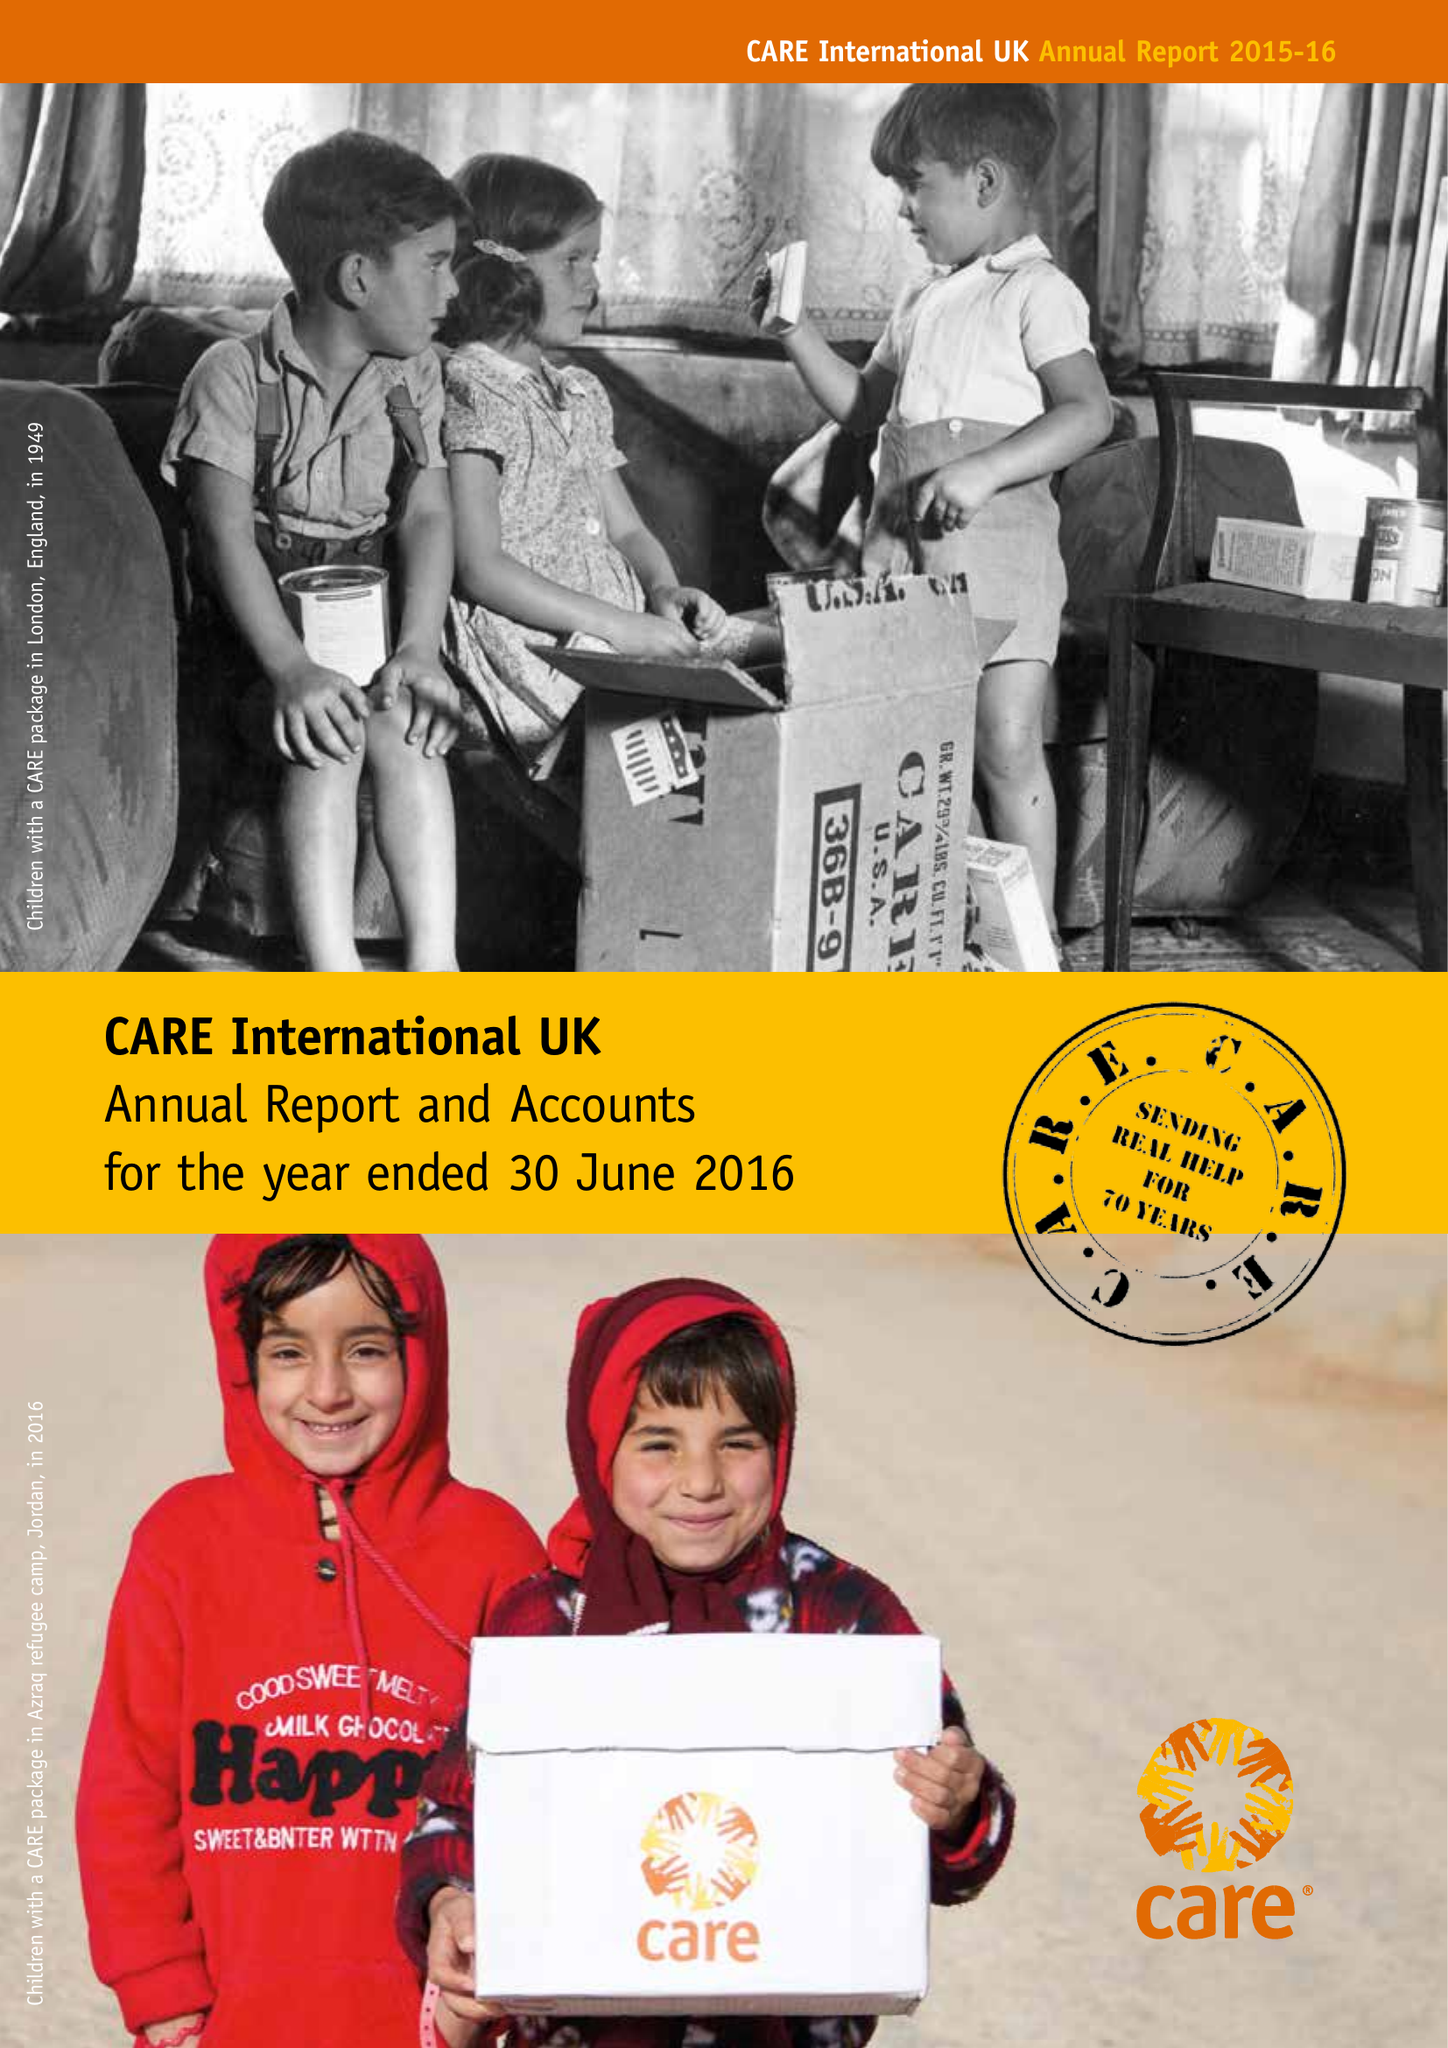What is the value for the spending_annually_in_british_pounds?
Answer the question using a single word or phrase. 66822000.00 